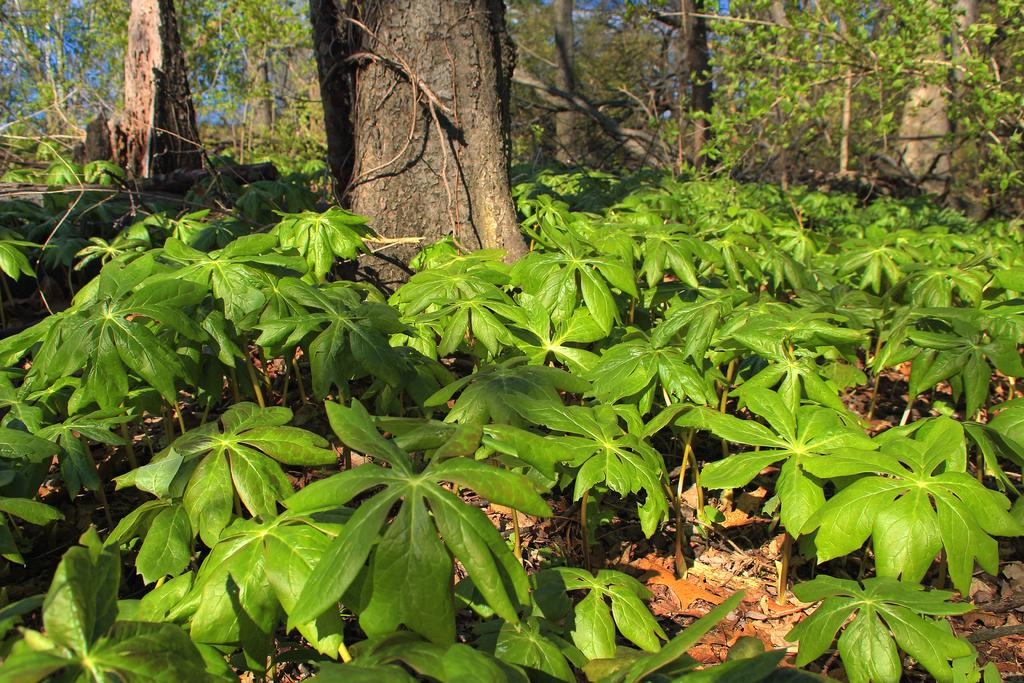What type of vegetation is the main subject of the image? There is a tree in the image. What other types of vegetation are present around the tree? There are small plants and bushes around the tree. What type of underwear is the grandmother wearing in the image? There is no grandmother or underwear present in the image. 